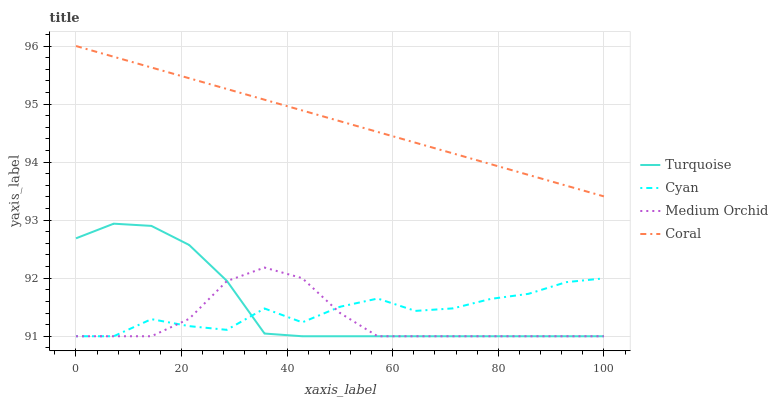Does Medium Orchid have the minimum area under the curve?
Answer yes or no. Yes. Does Coral have the maximum area under the curve?
Answer yes or no. Yes. Does Turquoise have the minimum area under the curve?
Answer yes or no. No. Does Turquoise have the maximum area under the curve?
Answer yes or no. No. Is Coral the smoothest?
Answer yes or no. Yes. Is Cyan the roughest?
Answer yes or no. Yes. Is Turquoise the smoothest?
Answer yes or no. No. Is Turquoise the roughest?
Answer yes or no. No. Does Cyan have the lowest value?
Answer yes or no. Yes. Does Coral have the lowest value?
Answer yes or no. No. Does Coral have the highest value?
Answer yes or no. Yes. Does Turquoise have the highest value?
Answer yes or no. No. Is Medium Orchid less than Coral?
Answer yes or no. Yes. Is Coral greater than Cyan?
Answer yes or no. Yes. Does Turquoise intersect Medium Orchid?
Answer yes or no. Yes. Is Turquoise less than Medium Orchid?
Answer yes or no. No. Is Turquoise greater than Medium Orchid?
Answer yes or no. No. Does Medium Orchid intersect Coral?
Answer yes or no. No. 